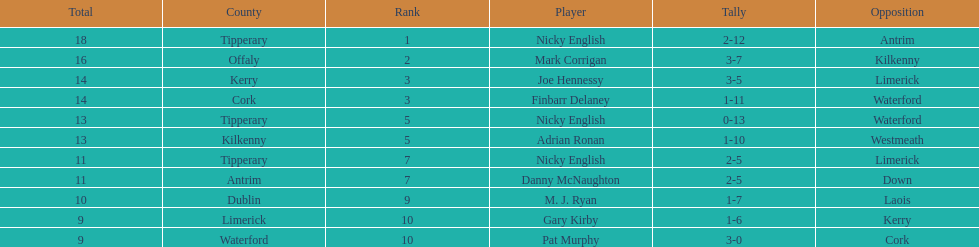What was the combined total of nicky english and mark corrigan? 34. 